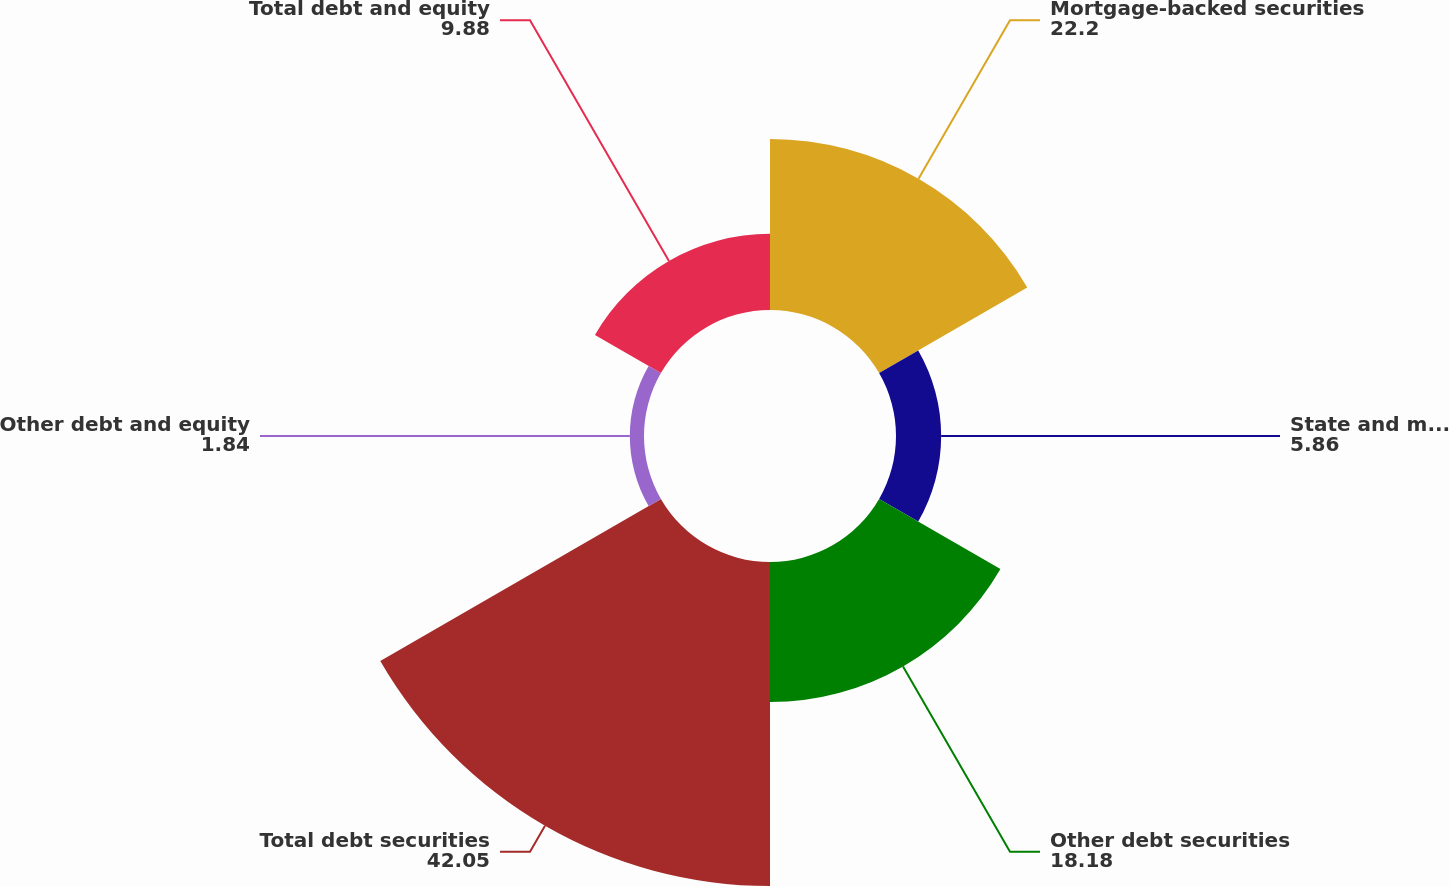Convert chart. <chart><loc_0><loc_0><loc_500><loc_500><pie_chart><fcel>Mortgage-backed securities<fcel>State and municipal<fcel>Other debt securities<fcel>Total debt securities<fcel>Other debt and equity<fcel>Total debt and equity<nl><fcel>22.2%<fcel>5.86%<fcel>18.18%<fcel>42.05%<fcel>1.84%<fcel>9.88%<nl></chart> 